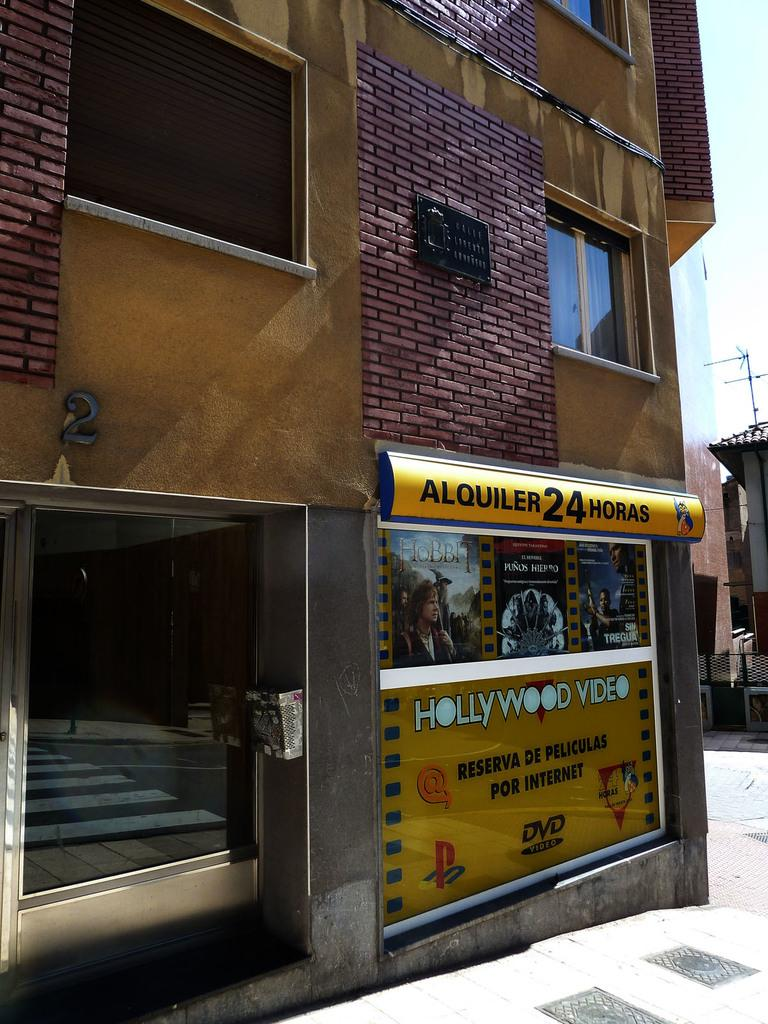<image>
Present a compact description of the photo's key features. A 24 hour corner store that says Hollywood Video on its side. 